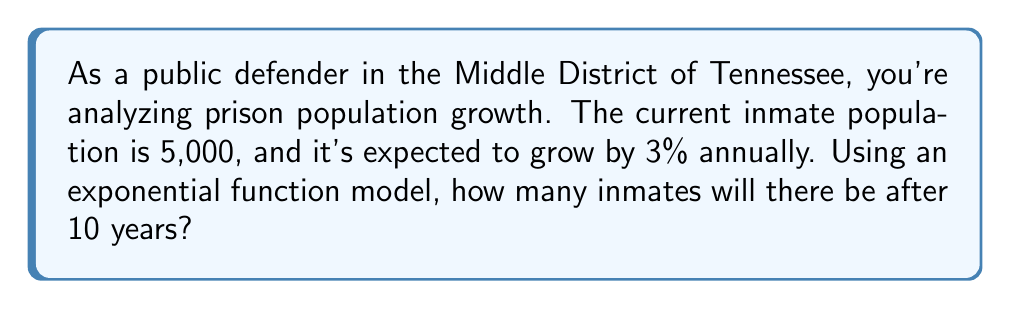Solve this math problem. Let's approach this step-by-step:

1) The exponential growth function is given by:
   $$P(t) = P_0 \cdot (1 + r)^t$$
   Where:
   $P(t)$ is the population after time $t$
   $P_0$ is the initial population
   $r$ is the growth rate (as a decimal)
   $t$ is the time in years

2) We know:
   $P_0 = 5,000$ (initial population)
   $r = 0.03$ (3% annual growth rate)
   $t = 10$ years

3) Let's substitute these values into our equation:
   $$P(10) = 5,000 \cdot (1 + 0.03)^{10}$$

4) Simplify inside the parentheses:
   $$P(10) = 5,000 \cdot (1.03)^{10}$$

5) Calculate $(1.03)^{10}$:
   $$P(10) = 5,000 \cdot 1.3439$$

6) Multiply:
   $$P(10) = 6,719.58$$

7) Since we're dealing with people, we round to the nearest whole number:
   $$P(10) \approx 6,720$$
Answer: 6,720 inmates 